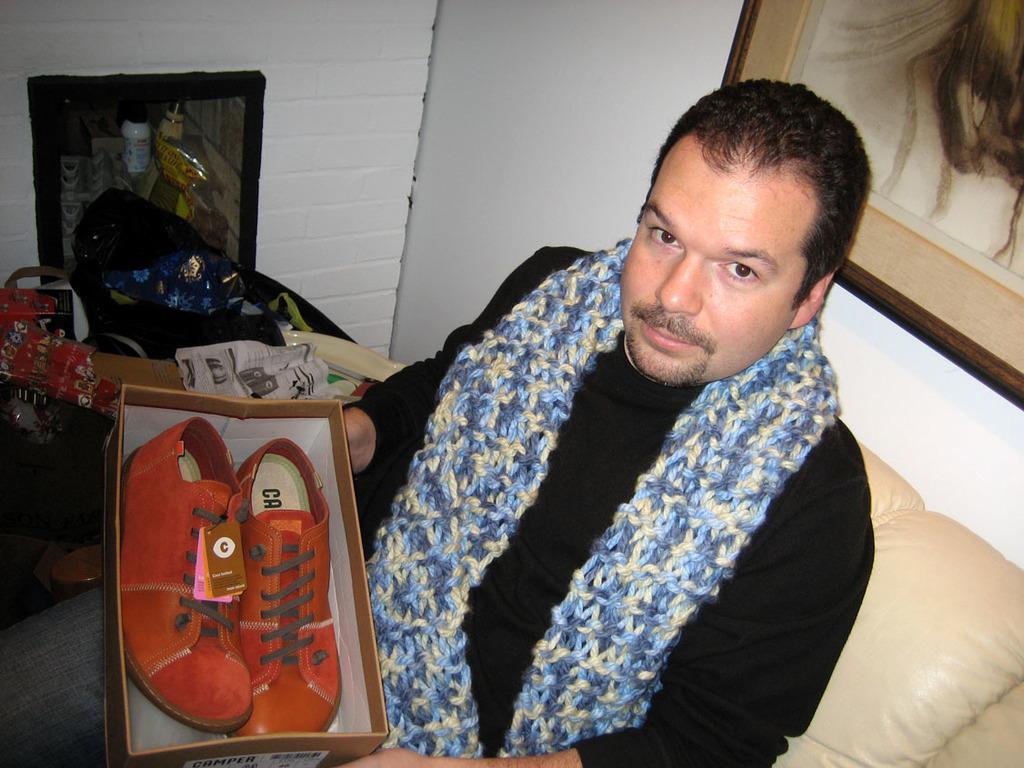Please provide a concise description of this image. This is the man sitting on the couch. On the right side of the image, I can see a photo frame, which is attached to a wall. I can see a pair of shoes, which are in a cardboard box. These are the objects, which are kept on the floor. 